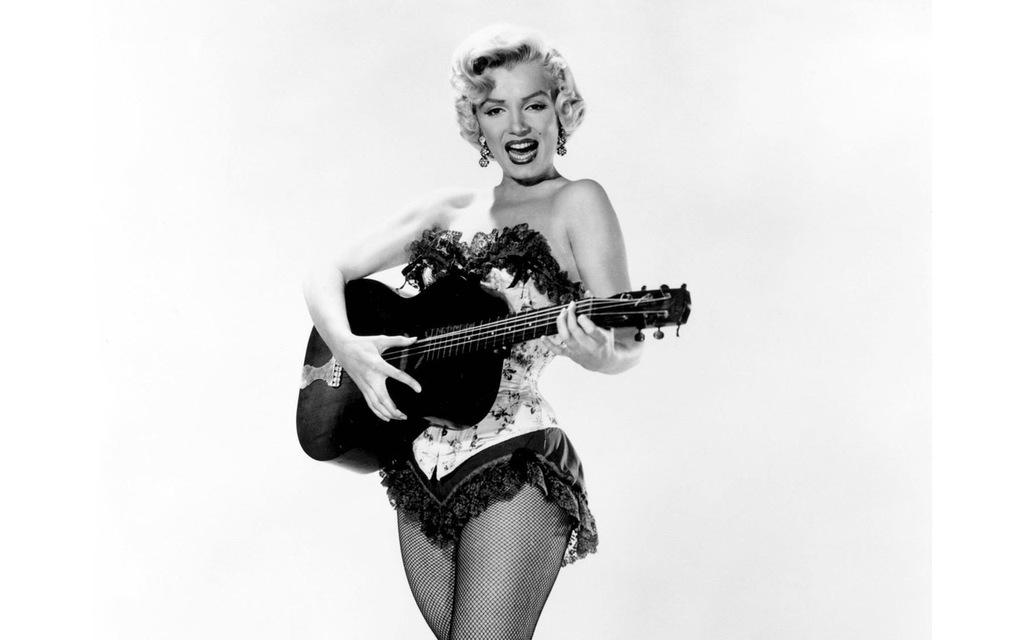Who is the main subject in the image? There is a lady in the image. Where is the lady positioned in the image? The lady is standing at the center of the image. What is the lady holding in her hand? The lady is holding a guitar in her hand. What color is the background of the image? The background of the image is white in color. What type of kettle is visible in the image? There is no kettle present in the image. What month is it in the image? The image does not provide any information about the month. 